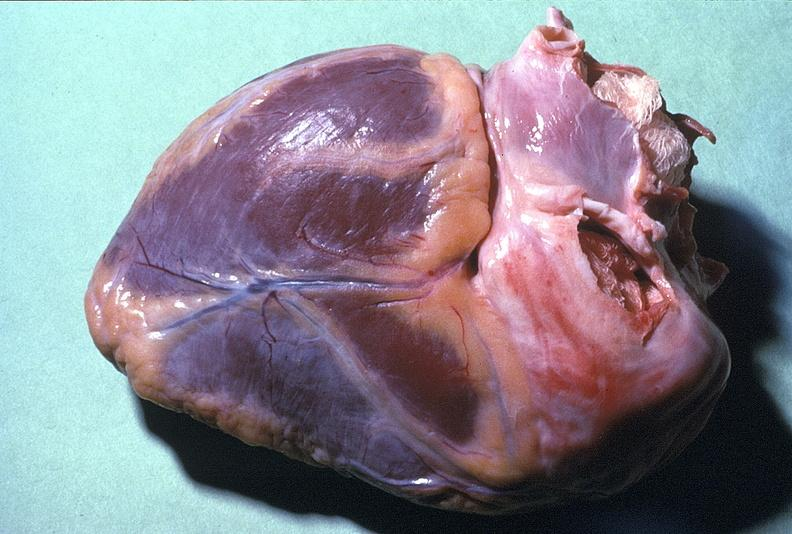s cardiovascular present?
Answer the question using a single word or phrase. Yes 